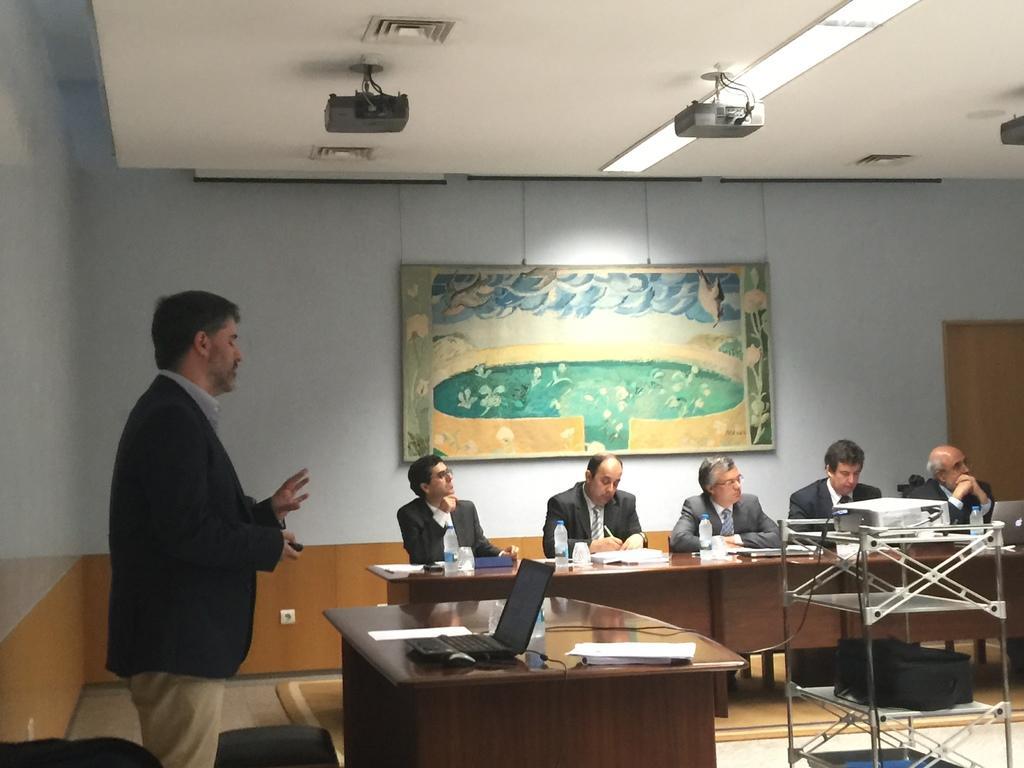How would you summarize this image in a sentence or two? In this image I can see number of people were few of them are sitting and a man is standing. I can also see few tables and a laptop on this table. Here I can see three projectors and a frame on this wall. 